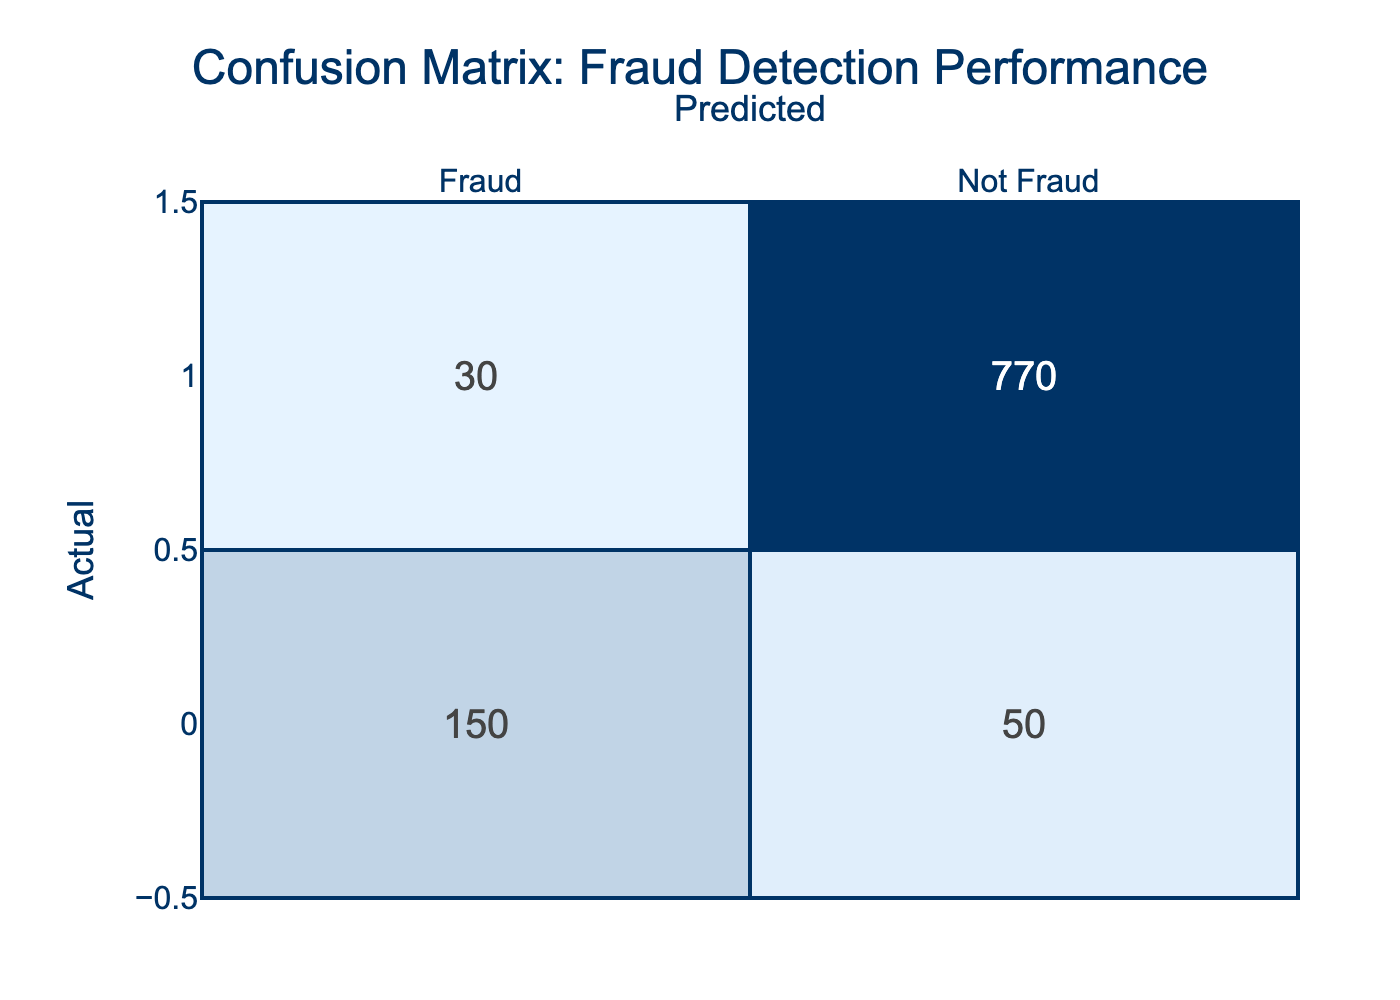What is the total number of actual fraud cases? To find the total number of actual fraud cases, we need the value from the first row where "Actual" is "Fraud". From the table, the total actual fraud cases are 150.
Answer: 150 What is the total number of cases predicted as not fraud? To determine this, we sum the values in the second column under the predicted "Not Fraud" classification. This gives us 50 (predicted fraud but actual fraud) + 770 (predicted not fraud and actual not fraud) = 820.
Answer: 820 How many cases were incorrectly predicted as fraud (false positives)? This value is found in the cell corresponding to "Not Fraud" under "Predicted" and is equal to 30. It indicates the cases that were falsely identified as fraud when they were not.
Answer: 30 What is the total number of cases predicted as fraud? The total predicted fraud cases consist of the sum of actual fraud cases predicted as fraud (150) and the cases incorrectly predicted as fraud (30). Thus total predicted fraud = 150 + 30 = 180.
Answer: 180 What percentage of actual fraud cases were correctly predicted? To calculate this, we take the number of true positive cases (150), divide it by the total actual fraud cases (150 + 50 = 200), and multiply by 100 to get the percentage. So, (150/200) * 100 = 75%.
Answer: 75% Is the number of true negatives greater than the number of actual fraud cases? To answer this, we check the number of true negatives from the table, which is 770, and compare it to the actual fraud cases which is 200. Since 770 is greater than 200, the statement is true.
Answer: Yes How many total non-fraud cases were correctly predicted? The total non-fraud cases include those that were correctly predicted as "Not Fraud". This value is found in the "Not Fraud" row under "Predicted", which is equal to 770.
Answer: 770 If 100 more fraud cases were added, how would that affect the percentage of correct fraud predictions? The initial number of actual fraud cases is 200 (150 true positives + 50 false negatives). Adding 100 more fraud cases will change the total to 300. The true positive count remains 150, giving (150/300) * 100 = 50%. The percentage would decrease by 25%.
Answer: 50% What is the ratio of false negatives to true positives? To find the ratio of false negatives (50) to true positives (150), we calculate 50:150. This simplifies to 1:3. Therefore, the ratio of false negatives to true positives is 1 to 3.
Answer: 1:3 